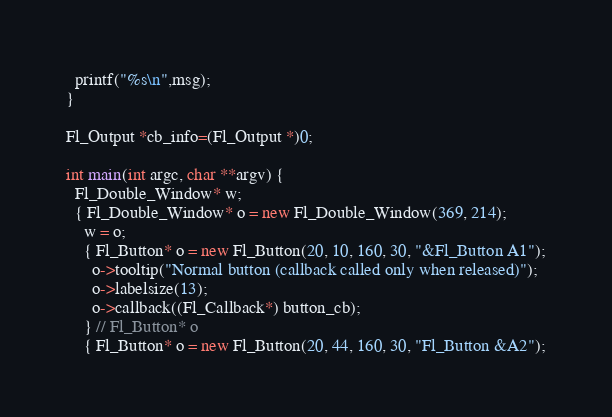Convert code to text. <code><loc_0><loc_0><loc_500><loc_500><_C++_>  printf("%s\n",msg);
}

Fl_Output *cb_info=(Fl_Output *)0;

int main(int argc, char **argv) {
  Fl_Double_Window* w;
  { Fl_Double_Window* o = new Fl_Double_Window(369, 214);
    w = o;
    { Fl_Button* o = new Fl_Button(20, 10, 160, 30, "&Fl_Button A1");
      o->tooltip("Normal button (callback called only when released)");
      o->labelsize(13);
      o->callback((Fl_Callback*) button_cb);
    } // Fl_Button* o
    { Fl_Button* o = new Fl_Button(20, 44, 160, 30, "Fl_Button &A2");</code> 